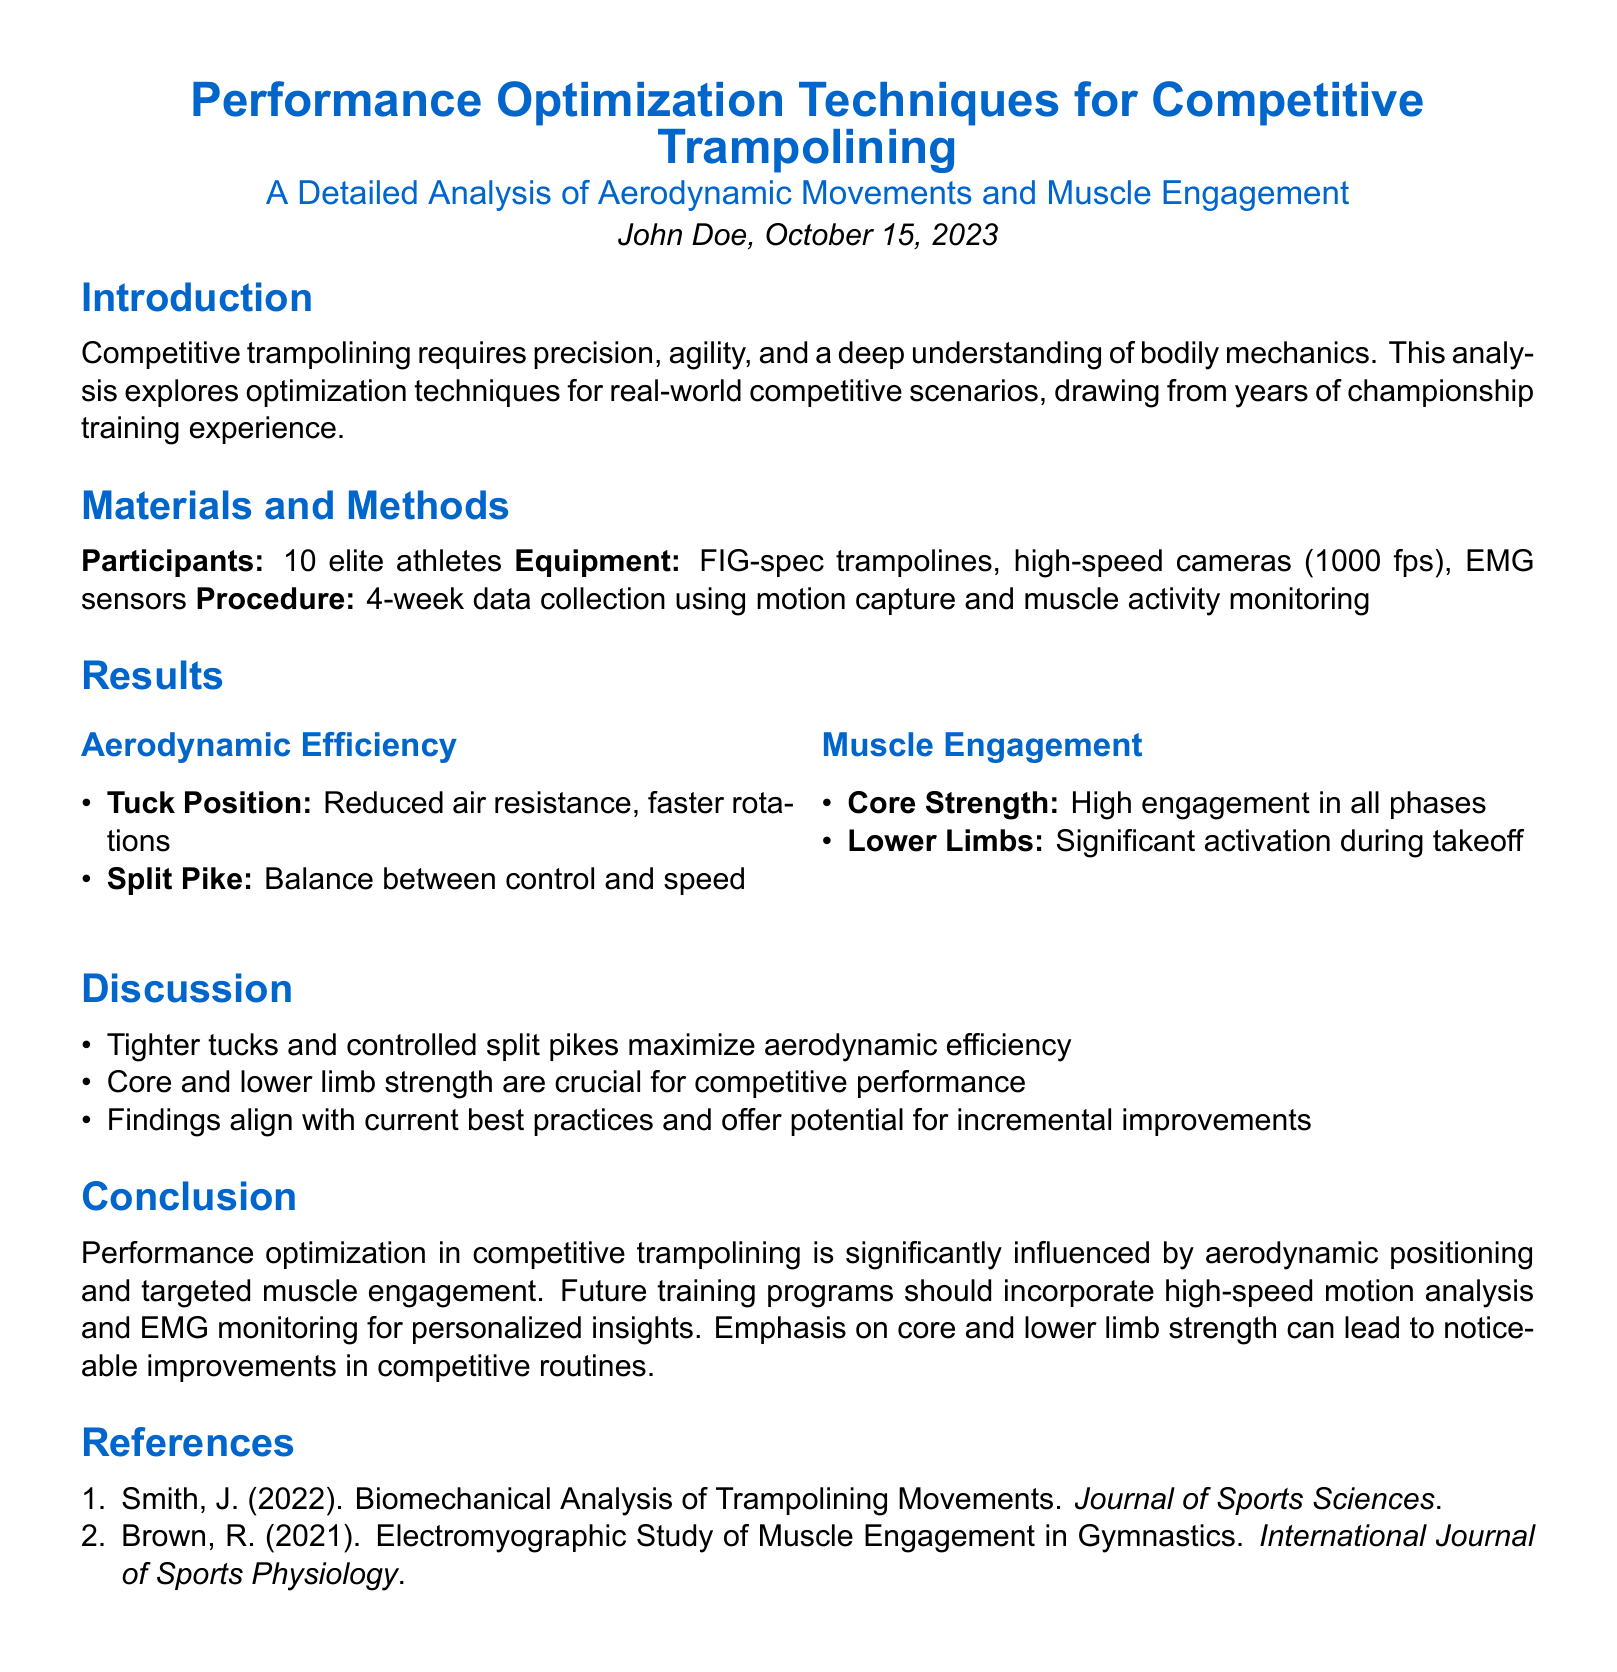what is the title of the report? The title of the report provides a central theme and focus of the study on trampolining optimization techniques.
Answer: Performance Optimization Techniques for Competitive Trampolining who authored the report? The author is listed prominently at the beginning of the document, indicating who conducted the research.
Answer: John Doe how many participants were involved in the study? The number of participants is stated in the Materials and Methods section, reflecting the sample size of the study.
Answer: 10 elite athletes what are the two main techniques analyzed for aerodynamic efficiency? The results section identifies key techniques related to aerodynamic movements that were evaluated for their effectiveness.
Answer: Tuck Position, Split Pike what does the report suggest is crucial for competitive performance? The discussion highlights key factors that contribute to improved performance in competitive trampolining based on the analysis.
Answer: Core and lower limb strength what equipment was used for the data collection? The procedure section lists the types of equipment utilized for capturing the required data during the study.
Answer: FIG-spec trampolines, high-speed cameras, EMG sensors when was the report published? The date of publication is mentioned in the introductory section, which signifies the timeliness of the research findings.
Answer: October 15, 2023 which areas of muscle engagement were highlighted in the results? The results outlined specific muscle groups that were significantly engaged during competitive performance, emphasizing their importance.
Answer: Core Strength, Lower Limbs what is the conclusion of the report regarding future training programs? The conclusion provides a recommendation based on the study findings, indicating a direction for further training improvements.
Answer: Incorporate high-speed motion analysis and EMG monitoring 